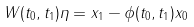<formula> <loc_0><loc_0><loc_500><loc_500>W ( t _ { 0 } , t _ { 1 } ) \eta = x _ { 1 } - \phi ( t _ { 0 } , t _ { 1 } ) x _ { 0 }</formula> 